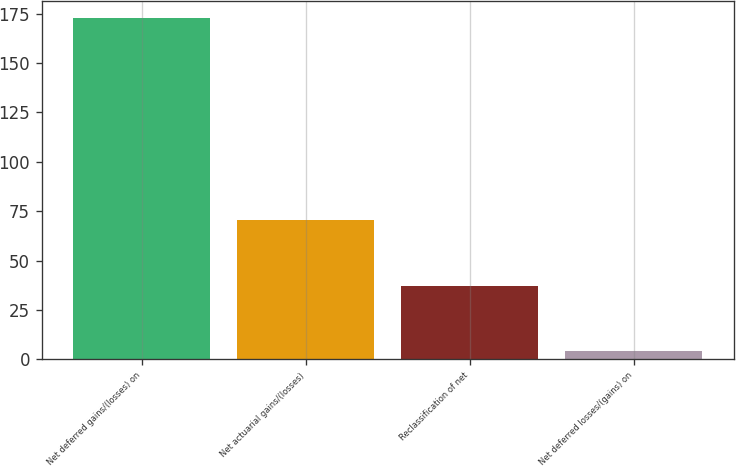Convert chart to OTSL. <chart><loc_0><loc_0><loc_500><loc_500><bar_chart><fcel>Net deferred gains/(losses) on<fcel>Net actuarial gains/(losses)<fcel>Reclassification of net<fcel>Net deferred losses/(gains) on<nl><fcel>173<fcel>70.4<fcel>37.2<fcel>4<nl></chart> 